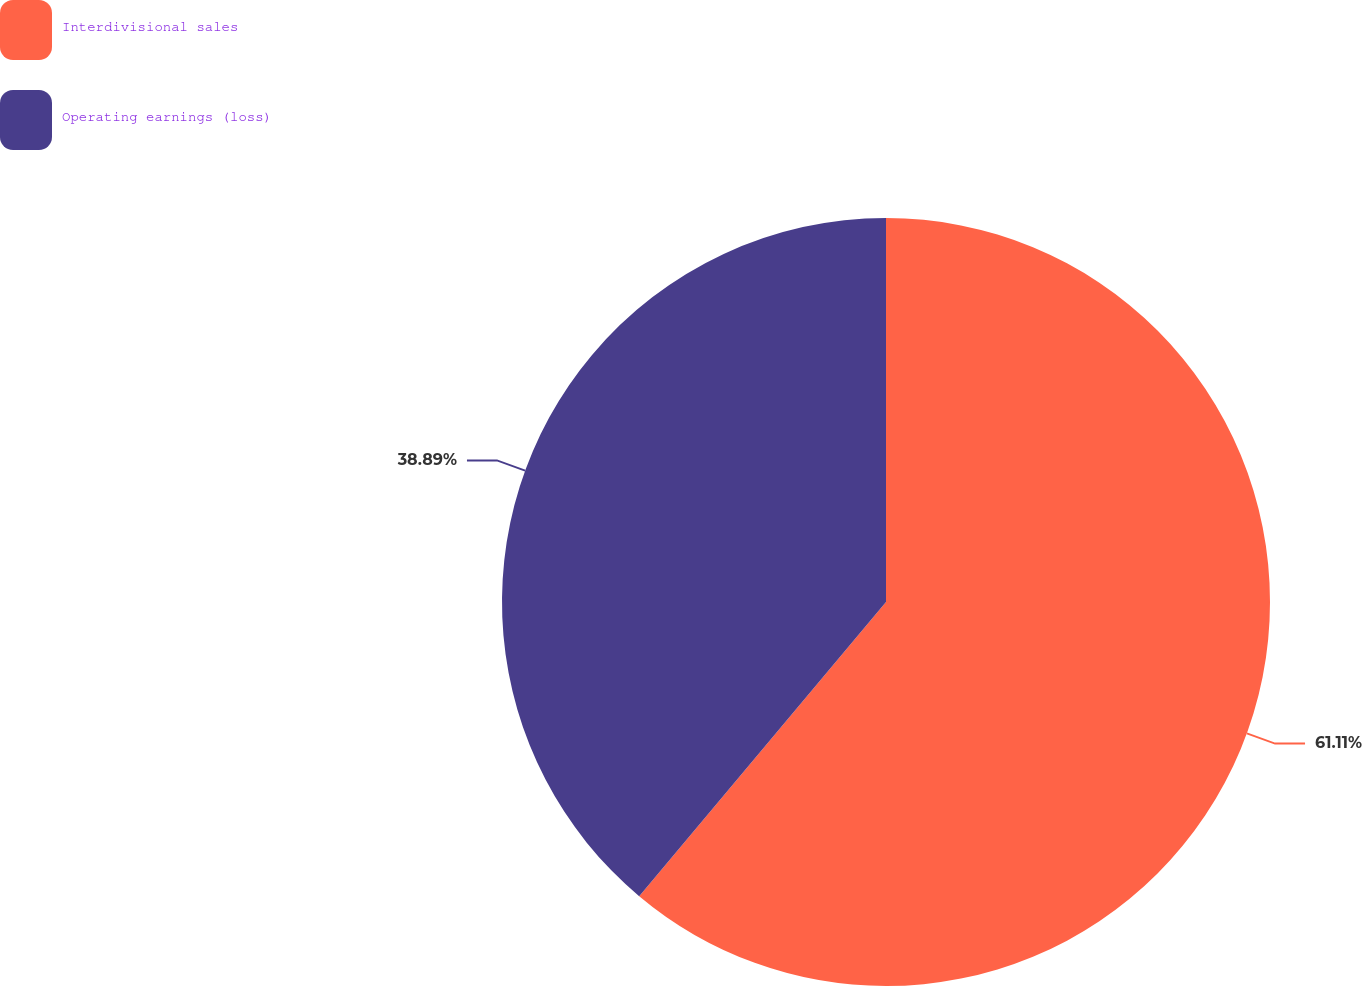Convert chart to OTSL. <chart><loc_0><loc_0><loc_500><loc_500><pie_chart><fcel>Interdivisional sales<fcel>Operating earnings (loss)<nl><fcel>61.11%<fcel>38.89%<nl></chart> 